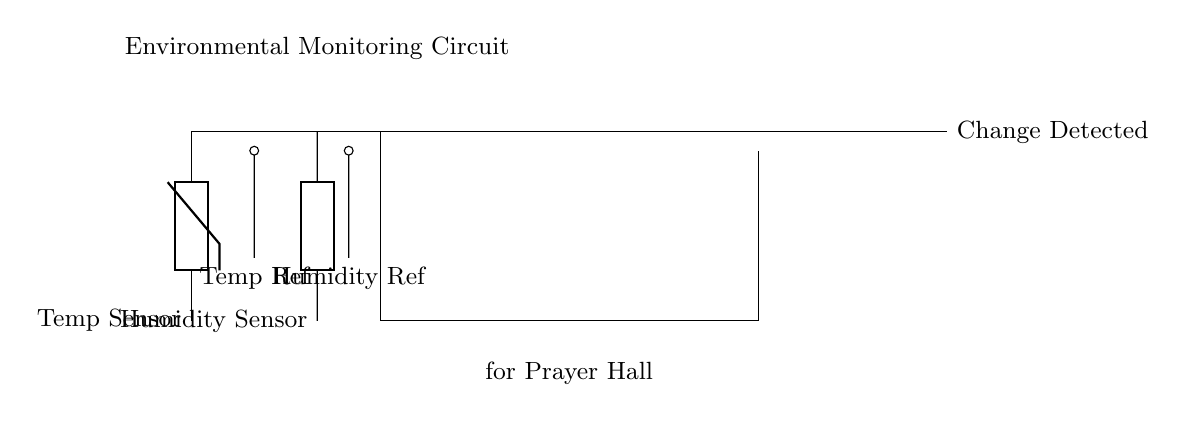What type of sensors are used in this circuit? The circuit uses a temperature sensor and a humidity sensor, as indicated by the labels on the left side of the diagram.
Answer: Temperature Sensor and Humidity Sensor What do the XOR gates signify in this monitoring circuit? The XOR gates are used to evaluate the differences in output from the temperature and humidity sensors, indicating whether a significant change has occurred by producing a high signal when the inputs differ.
Answer: Change Detected How many XOR gates are used in the circuit? There are three XOR gates present in the circuit diagram, indicating their use for making changes in output based on sensor comparisons.
Answer: Three What is the purpose of the reference voltages in this circuit? Reference voltages are set for both the temperature and humidity sensors; they represent baseline values which help in comparing current sensor outputs to detect changes.
Answer: Baseline comparison If the humidity increases while the temperature remains constant, what would the output be? If the humidity increases (high input) while the temperature stays the same (low input), one input to the XOR gate will differ from the other, leading to a high output indicating a change.
Answer: Change Detected What can be inferred if the "Change Detected" output is low? A low output suggests that either there is no significant change in temperature or humidity, or both sensor inputs are equal, meaning that environmental conditions in the prayer hall are stable.
Answer: No Change 